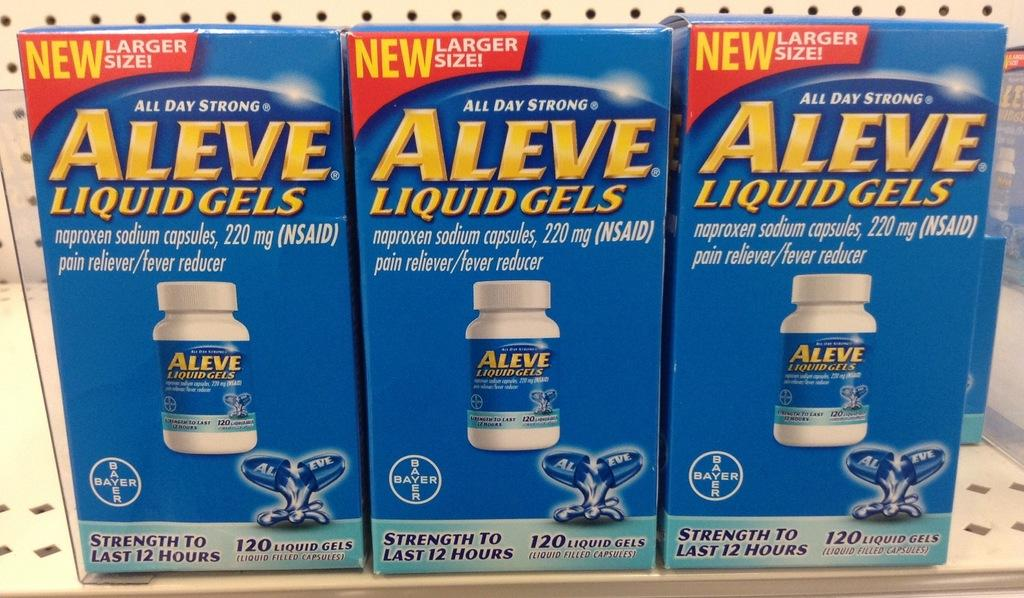<image>
Create a compact narrative representing the image presented. A shelf of Aleve Liquid Gels in blue boxes. 